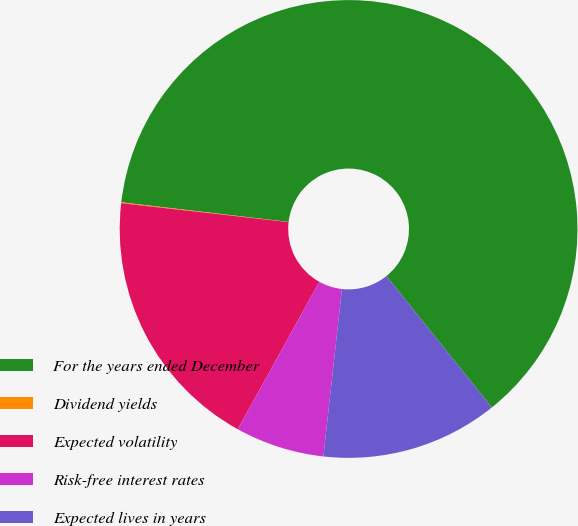Convert chart. <chart><loc_0><loc_0><loc_500><loc_500><pie_chart><fcel>For the years ended December<fcel>Dividend yields<fcel>Expected volatility<fcel>Risk-free interest rates<fcel>Expected lives in years<nl><fcel>62.37%<fcel>0.06%<fcel>18.75%<fcel>6.29%<fcel>12.52%<nl></chart> 